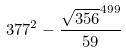Convert formula to latex. <formula><loc_0><loc_0><loc_500><loc_500>3 7 7 ^ { 2 } - \frac { \sqrt { 3 5 6 } ^ { 4 9 9 } } { 5 9 }</formula> 